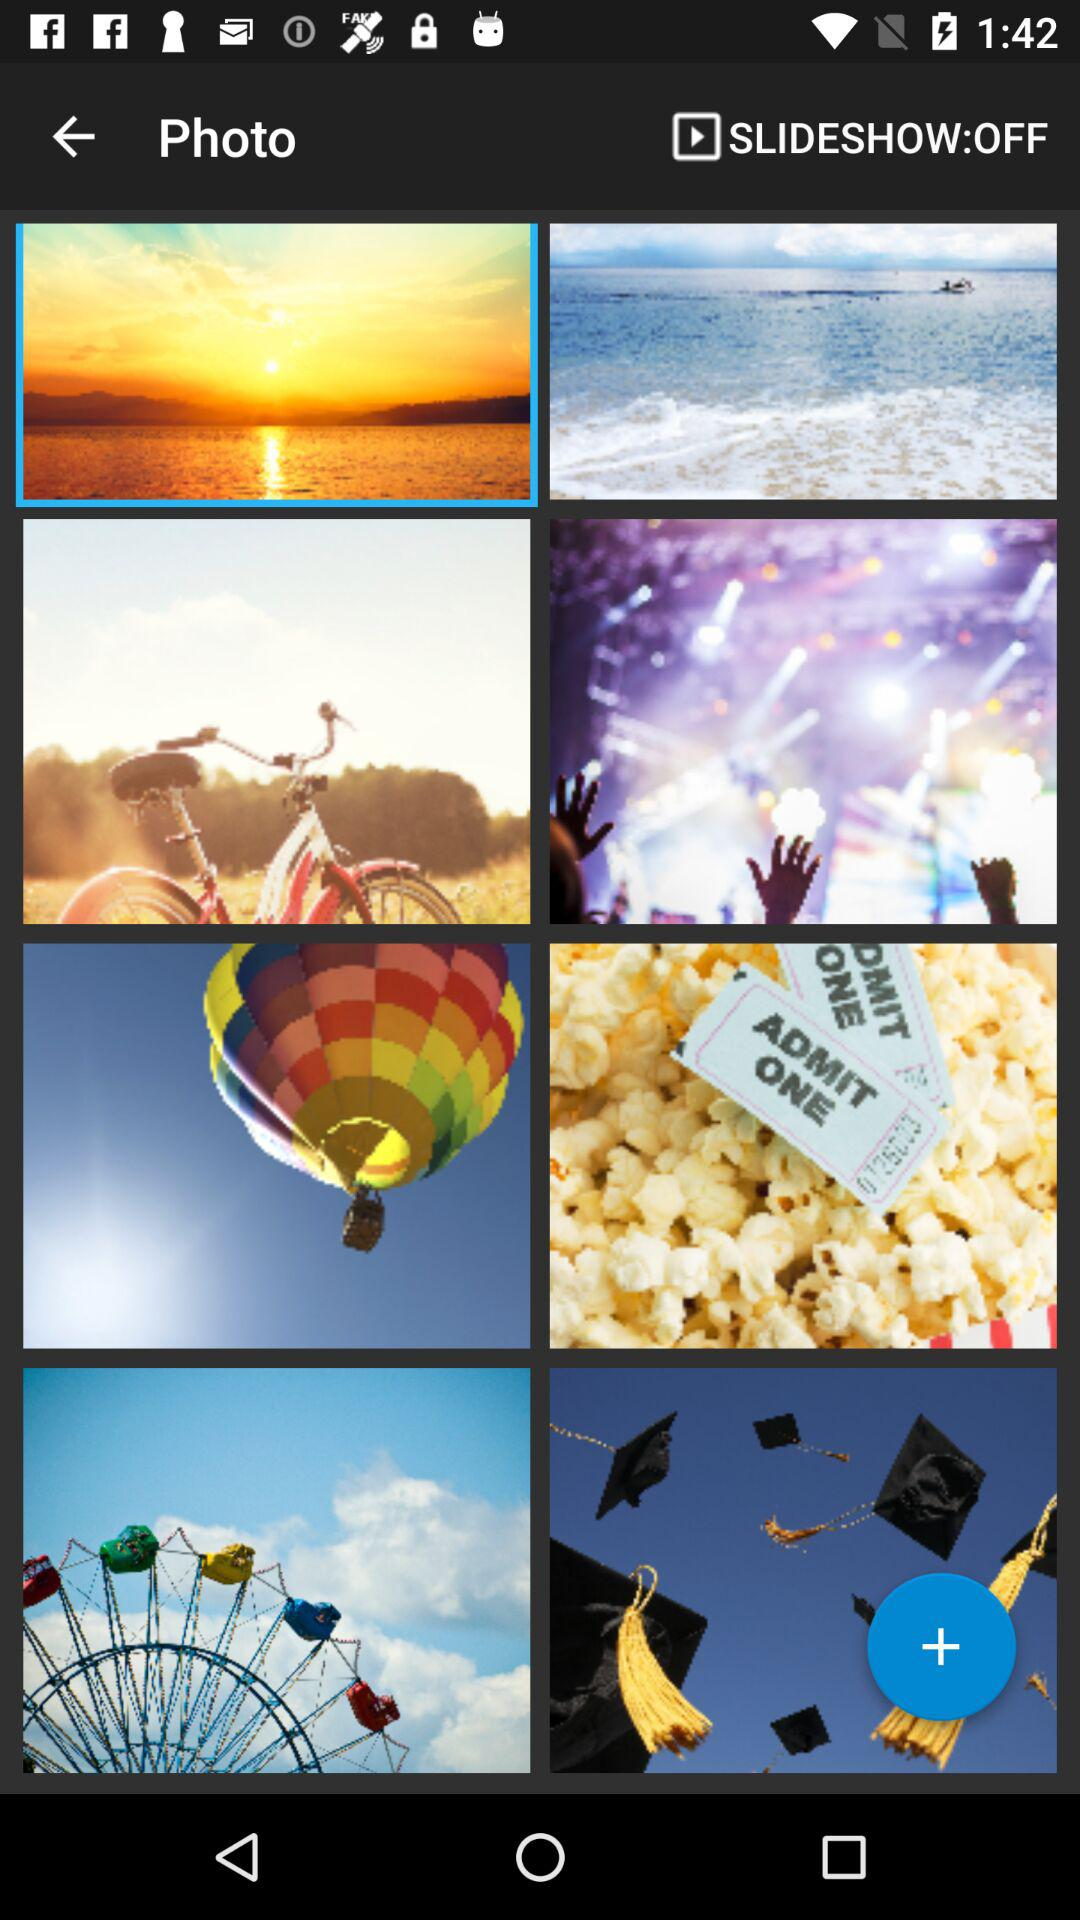What is the status of "SLIDESHOW"? The status is "off". 